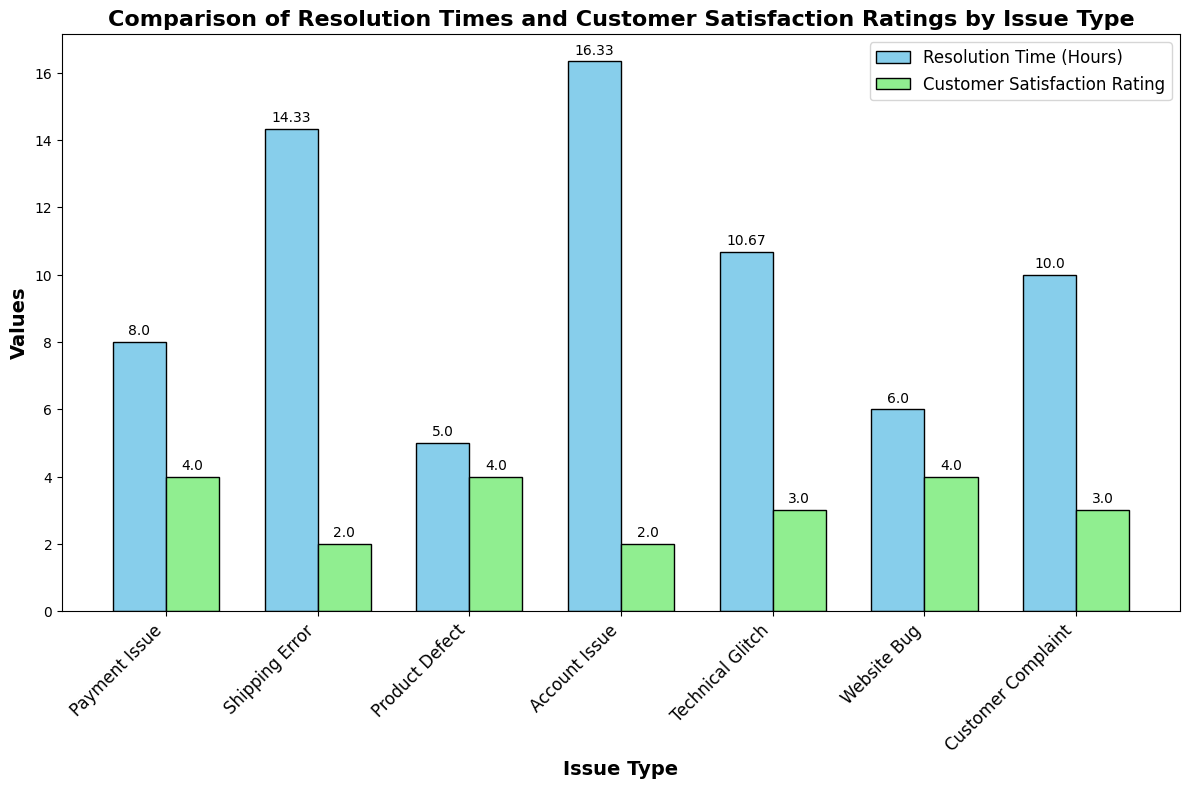Which issue type has the highest average resolution time? Look for the bar representing 'Resolution Time (Hours)' and find the bar with the tallest height. This corresponds to the highest average resolution time.
Answer: Product Defect Which issue type has the highest average customer satisfaction rating? Look for the bar representing 'Customer Satisfaction Rating' and find the bar with the tallest height. This corresponds to the highest average customer satisfaction rating.
Answer: Payment Issue Is the average resolution time for 'Shipping Error' more or less than 'Technical Glitch'? Compare the height of the 'Resolution Time (Hours)' bars for 'Shipping Error' and 'Technical Glitch'. The taller bar indicates a higher average resolution time.
Answer: More Which issue types have an average customer satisfaction rating of 3 or less? Identify the 'Customer Satisfaction Rating' bars with a height equal to or less than 3 and find their corresponding issue types.
Answer: Shipping Error, Product Defect, Customer Complaint, Website Bug By how much does the average resolution time for 'Product Defect' exceed that of 'Payment Issue'? Subtract the average resolution time for 'Payment Issue' from the average resolution time for 'Product Defect'. Specifically, look at the height of the 'Resolution Time (Hours)' bars for these issues.
Answer: 9.67 hours Which issue type shows the largest difference between average resolution time and average customer satisfaction rating? Calculate the difference between the two bars for each issue type and find the largest difference. This requires mental computation for multiple issue types.
Answer: Product Defect Are there any issue types where the average customer satisfaction rating is higher than the average resolution time? Compare the heights of the 'Customer Satisfaction Rating' bars against the 'Resolution Time (Hours)' bars for each issue type and find cases where the customer satisfaction bar is taller.
Answer: No Which issue types have nearly equal average resolution times? Look for the issue types where the 'Resolution Time (Hours)' bar heights are close to each other.
Answer: Technical Glitch, Payment Issue What is the average customer satisfaction rating for 'Account Issue'? Read the height of the 'Customer Satisfaction Rating' bar for 'Account Issue'. This corresponds directly to the satisfaction rating.
Answer: 4 How does the average customer satisfaction rating for 'Website Bug' compare to 'Shipping Error'? Compare the height of the 'Customer Satisfaction Rating' bars for 'Website Bug' and 'Shipping Error'.
Answer: Higher 